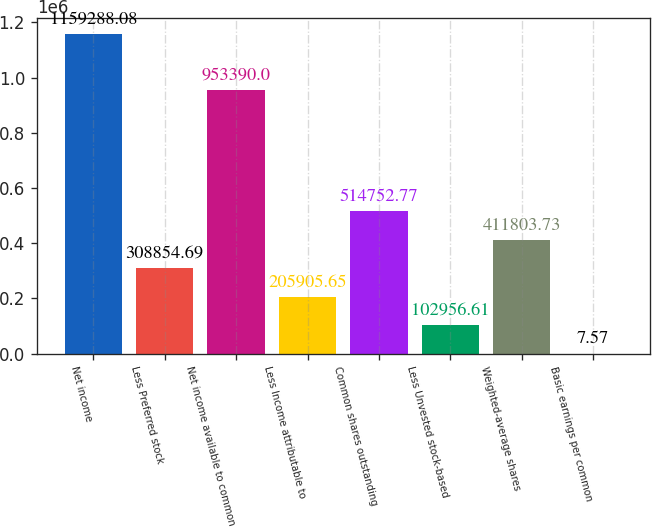Convert chart. <chart><loc_0><loc_0><loc_500><loc_500><bar_chart><fcel>Net income<fcel>Less Preferred stock<fcel>Net income available to common<fcel>Less Income attributable to<fcel>Common shares outstanding<fcel>Less Unvested stock-based<fcel>Weighted-average shares<fcel>Basic earnings per common<nl><fcel>1.15929e+06<fcel>308855<fcel>953390<fcel>205906<fcel>514753<fcel>102957<fcel>411804<fcel>7.57<nl></chart> 